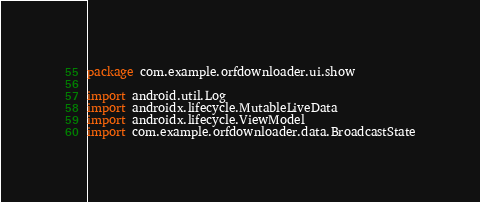Convert code to text. <code><loc_0><loc_0><loc_500><loc_500><_Kotlin_>package com.example.orfdownloader.ui.show

import android.util.Log
import androidx.lifecycle.MutableLiveData
import androidx.lifecycle.ViewModel
import com.example.orfdownloader.data.BroadcastState</code> 